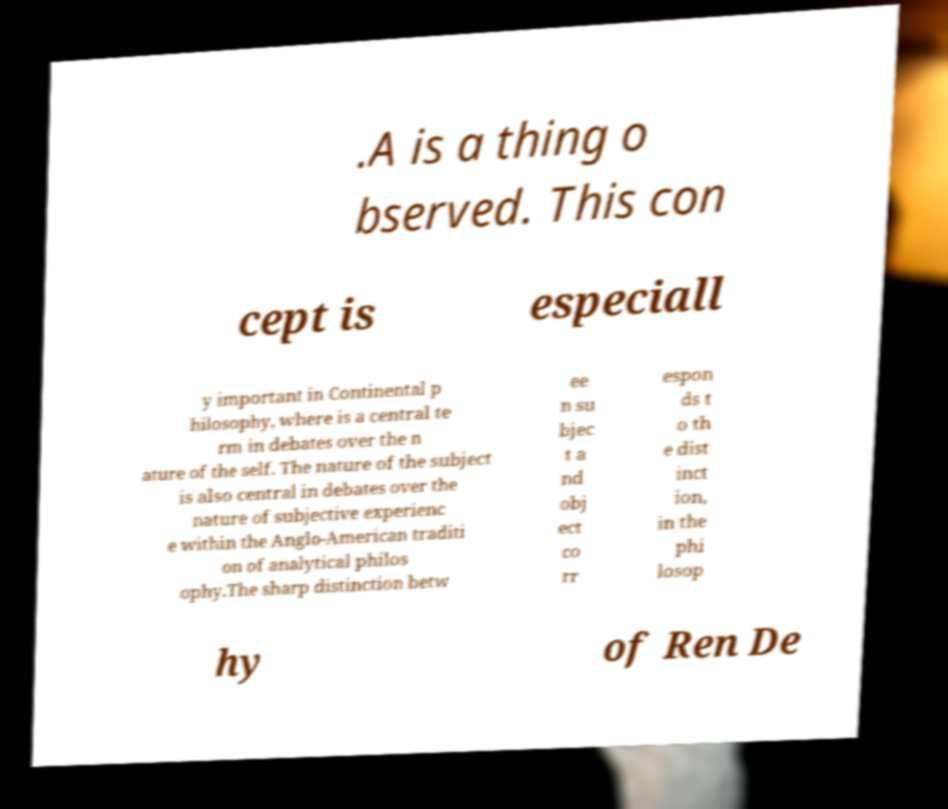Please identify and transcribe the text found in this image. .A is a thing o bserved. This con cept is especiall y important in Continental p hilosophy, where is a central te rm in debates over the n ature of the self. The nature of the subject is also central in debates over the nature of subjective experienc e within the Anglo-American traditi on of analytical philos ophy.The sharp distinction betw ee n su bjec t a nd obj ect co rr espon ds t o th e dist inct ion, in the phi losop hy of Ren De 